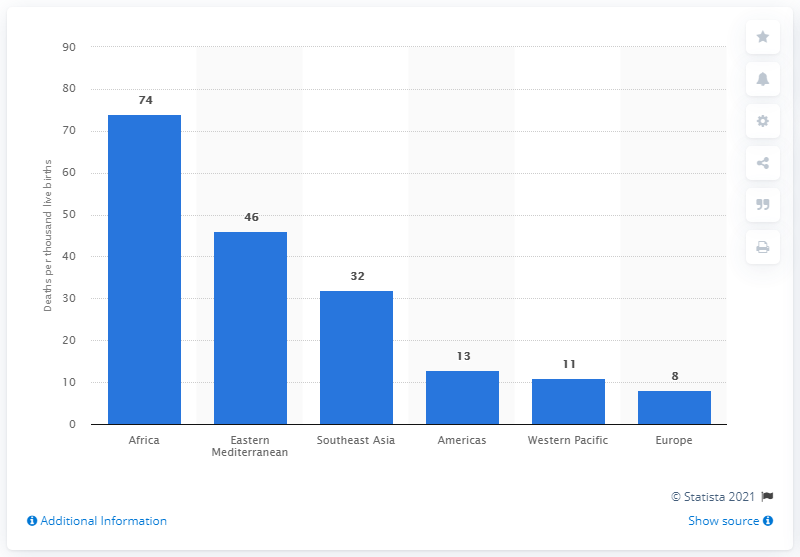List a handful of essential elements in this visual. In 2019, the child mortality rate in Africa was 74%. 